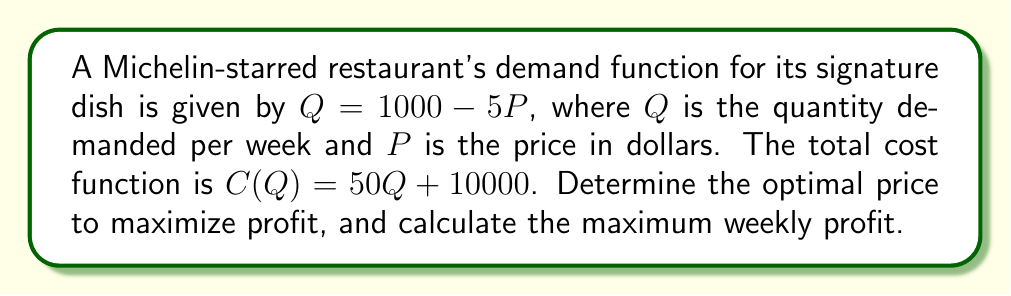Can you answer this question? Step 1: Express the profit function in terms of P.
Profit = Revenue - Cost
$\pi(P) = PQ - C(Q)$
$\pi(P) = P(1000 - 5P) - [50(1000 - 5P) + 10000]$
$\pi(P) = 1000P - 5P^2 - 50000 + 250P - 10000$
$\pi(P) = -5P^2 + 1250P - 60000$

Step 2: Find the derivative of the profit function.
$$\frac{d\pi}{dP} = -10P + 1250$$

Step 3: Set the derivative equal to zero and solve for P.
$-10P + 1250 = 0$
$-10P = -1250$
$P = 125$

Step 4: Verify that this critical point yields a maximum by checking the second derivative.
$$\frac{d^2\pi}{dP^2} = -10$$
Since the second derivative is negative, $P = 125$ yields a maximum.

Step 5: Calculate the maximum profit by substituting $P = 125$ into the profit function.
$\pi(125) = -5(125)^2 + 1250(125) - 60000$
$= -78125 + 156250 - 60000$
$= 18125$
Answer: Optimal price: $125; Maximum weekly profit: $18,125 